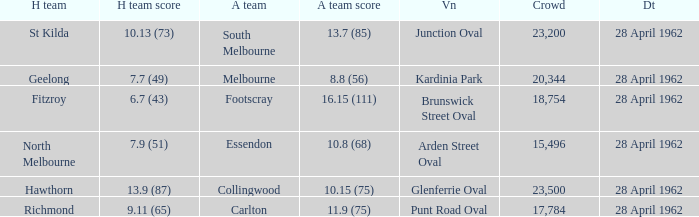At what venue did an away team score 10.15 (75)? Glenferrie Oval. 